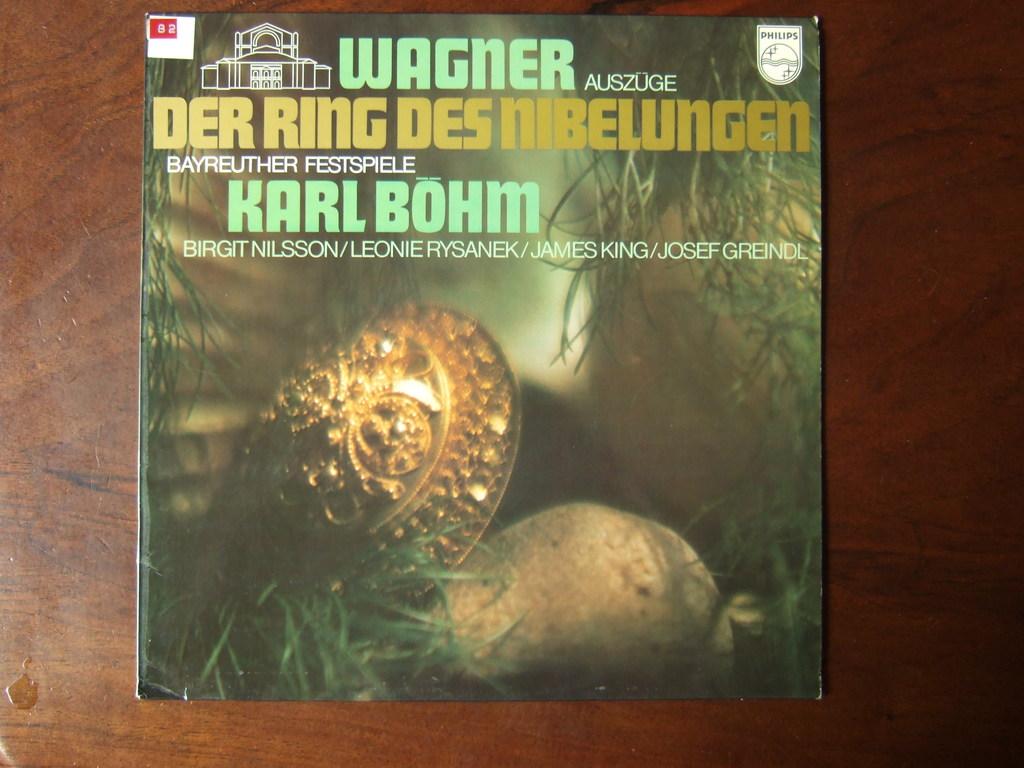Who wrote that book?
Your answer should be compact. Karl bohm. What word is in green at the top?
Your answer should be compact. Wagner. 